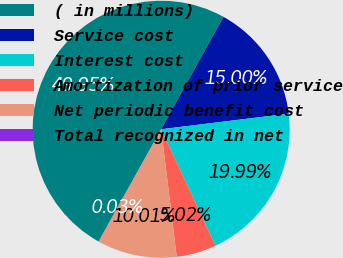<chart> <loc_0><loc_0><loc_500><loc_500><pie_chart><fcel>( in millions)<fcel>Service cost<fcel>Interest cost<fcel>Amortization of prior service<fcel>Net periodic benefit cost<fcel>Total recognized in net<nl><fcel>49.95%<fcel>15.0%<fcel>19.99%<fcel>5.02%<fcel>10.01%<fcel>0.03%<nl></chart> 